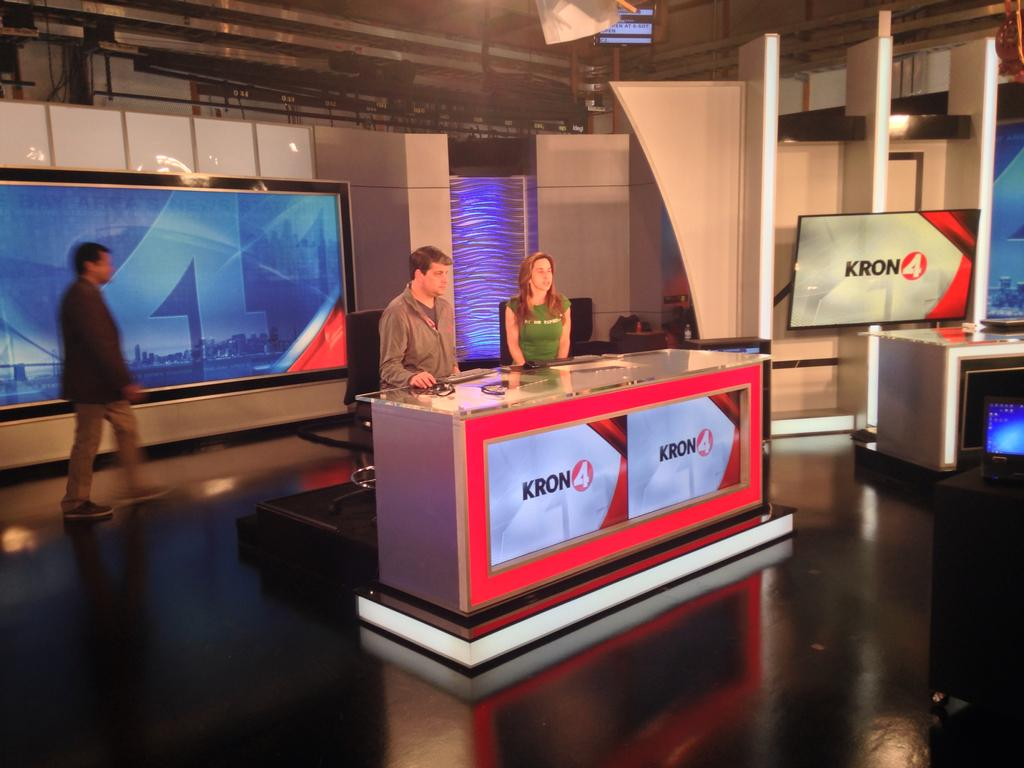<image>
Give a short and clear explanation of the subsequent image. A male and a Female news announcer for Kron 4 are sitting behind a desk, ready to go on air. 